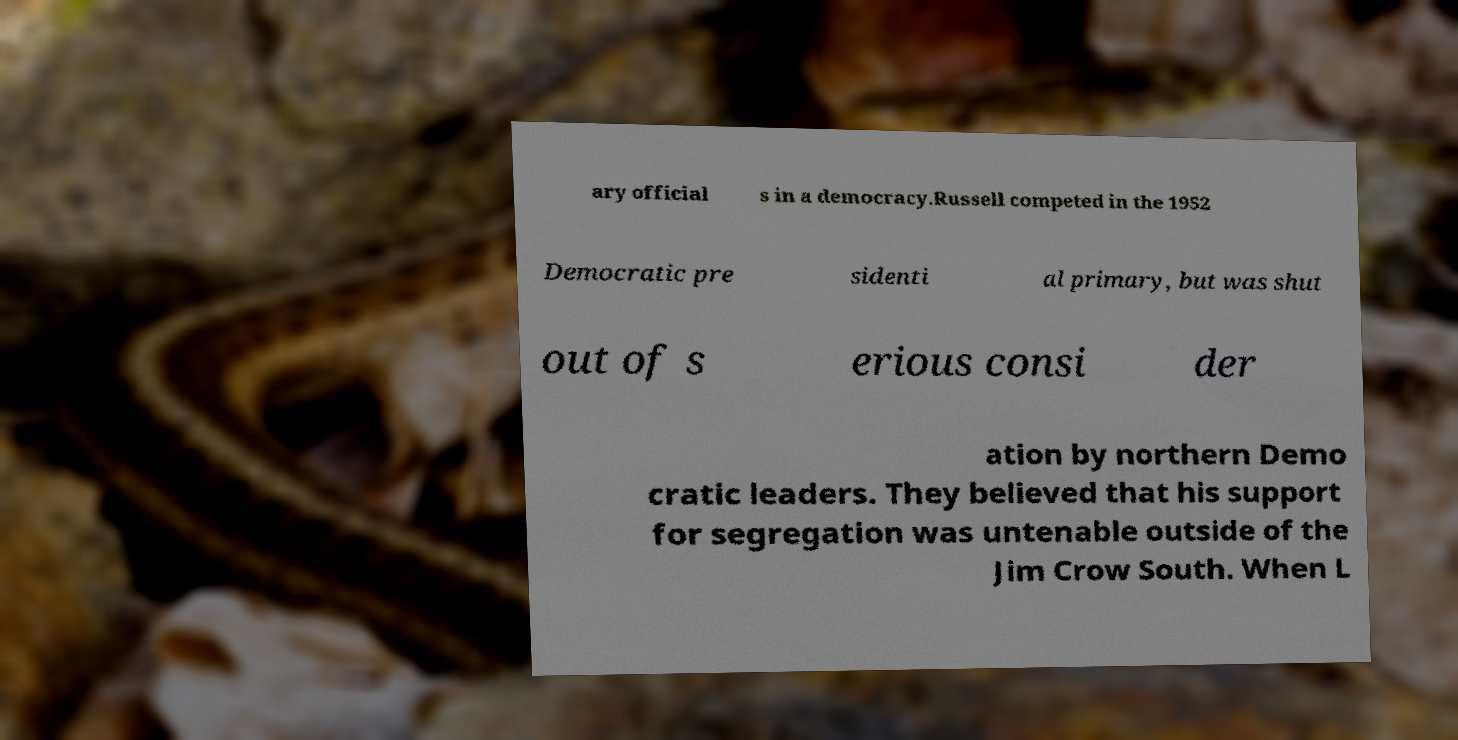Please identify and transcribe the text found in this image. ary official s in a democracy.Russell competed in the 1952 Democratic pre sidenti al primary, but was shut out of s erious consi der ation by northern Demo cratic leaders. They believed that his support for segregation was untenable outside of the Jim Crow South. When L 